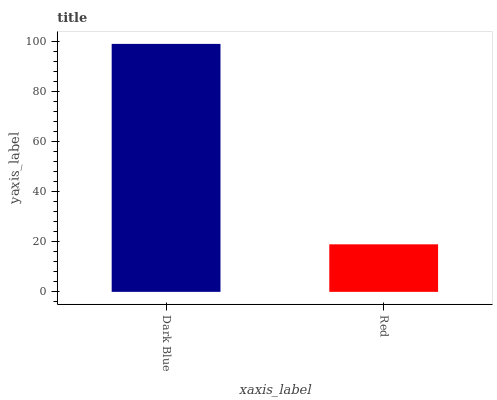Is Red the minimum?
Answer yes or no. Yes. Is Dark Blue the maximum?
Answer yes or no. Yes. Is Red the maximum?
Answer yes or no. No. Is Dark Blue greater than Red?
Answer yes or no. Yes. Is Red less than Dark Blue?
Answer yes or no. Yes. Is Red greater than Dark Blue?
Answer yes or no. No. Is Dark Blue less than Red?
Answer yes or no. No. Is Dark Blue the high median?
Answer yes or no. Yes. Is Red the low median?
Answer yes or no. Yes. Is Red the high median?
Answer yes or no. No. Is Dark Blue the low median?
Answer yes or no. No. 